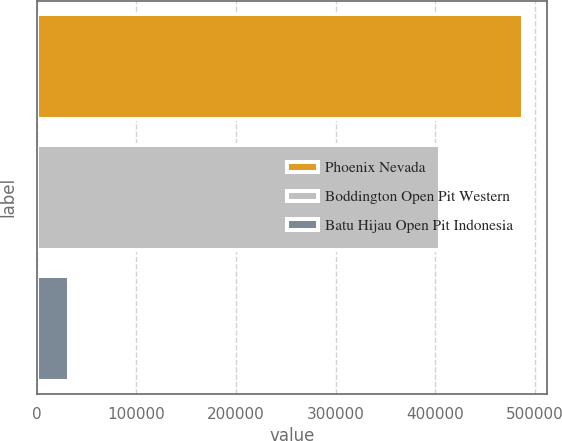Convert chart to OTSL. <chart><loc_0><loc_0><loc_500><loc_500><bar_chart><fcel>Phoenix Nevada<fcel>Boddington Open Pit Western<fcel>Batu Hijau Open Pit Indonesia<nl><fcel>487700<fcel>404300<fcel>32600<nl></chart> 